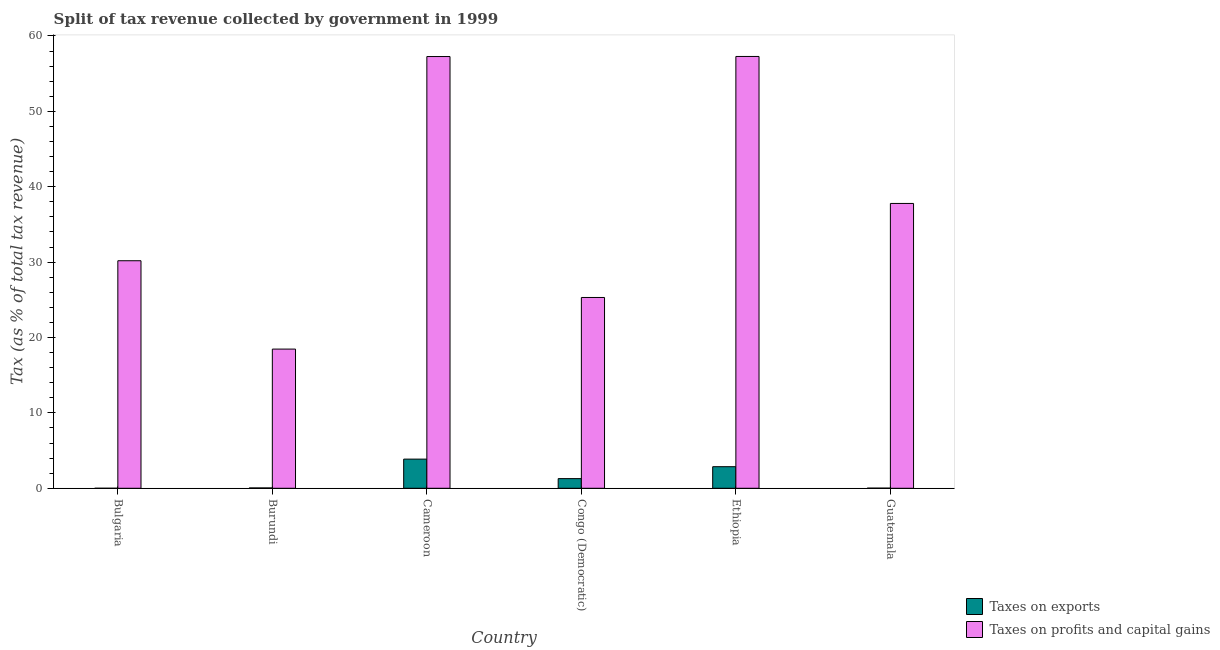How many different coloured bars are there?
Provide a short and direct response. 2. How many groups of bars are there?
Ensure brevity in your answer.  6. Are the number of bars per tick equal to the number of legend labels?
Offer a terse response. Yes. Are the number of bars on each tick of the X-axis equal?
Provide a succinct answer. Yes. How many bars are there on the 2nd tick from the right?
Make the answer very short. 2. What is the label of the 3rd group of bars from the left?
Your response must be concise. Cameroon. What is the percentage of revenue obtained from taxes on exports in Cameroon?
Ensure brevity in your answer.  3.87. Across all countries, what is the maximum percentage of revenue obtained from taxes on profits and capital gains?
Offer a very short reply. 57.28. Across all countries, what is the minimum percentage of revenue obtained from taxes on exports?
Ensure brevity in your answer.  0. In which country was the percentage of revenue obtained from taxes on exports maximum?
Ensure brevity in your answer.  Cameroon. In which country was the percentage of revenue obtained from taxes on profits and capital gains minimum?
Provide a succinct answer. Burundi. What is the total percentage of revenue obtained from taxes on profits and capital gains in the graph?
Provide a succinct answer. 226.28. What is the difference between the percentage of revenue obtained from taxes on exports in Ethiopia and that in Guatemala?
Your answer should be compact. 2.84. What is the difference between the percentage of revenue obtained from taxes on exports in Bulgaria and the percentage of revenue obtained from taxes on profits and capital gains in Burundi?
Give a very brief answer. -18.46. What is the average percentage of revenue obtained from taxes on exports per country?
Offer a very short reply. 1.35. What is the difference between the percentage of revenue obtained from taxes on exports and percentage of revenue obtained from taxes on profits and capital gains in Burundi?
Ensure brevity in your answer.  -18.42. What is the ratio of the percentage of revenue obtained from taxes on exports in Bulgaria to that in Congo (Democratic)?
Offer a very short reply. 0. Is the percentage of revenue obtained from taxes on exports in Burundi less than that in Cameroon?
Provide a succinct answer. Yes. What is the difference between the highest and the second highest percentage of revenue obtained from taxes on profits and capital gains?
Offer a very short reply. 0.01. What is the difference between the highest and the lowest percentage of revenue obtained from taxes on exports?
Provide a succinct answer. 3.87. What does the 1st bar from the left in Burundi represents?
Give a very brief answer. Taxes on exports. What does the 1st bar from the right in Ethiopia represents?
Ensure brevity in your answer.  Taxes on profits and capital gains. How many bars are there?
Make the answer very short. 12. Are all the bars in the graph horizontal?
Give a very brief answer. No. How many countries are there in the graph?
Make the answer very short. 6. Are the values on the major ticks of Y-axis written in scientific E-notation?
Make the answer very short. No. Does the graph contain grids?
Offer a very short reply. No. Where does the legend appear in the graph?
Keep it short and to the point. Bottom right. How many legend labels are there?
Provide a succinct answer. 2. What is the title of the graph?
Provide a succinct answer. Split of tax revenue collected by government in 1999. Does "Tetanus" appear as one of the legend labels in the graph?
Ensure brevity in your answer.  No. What is the label or title of the X-axis?
Ensure brevity in your answer.  Country. What is the label or title of the Y-axis?
Your answer should be very brief. Tax (as % of total tax revenue). What is the Tax (as % of total tax revenue) in Taxes on exports in Bulgaria?
Provide a succinct answer. 0. What is the Tax (as % of total tax revenue) of Taxes on profits and capital gains in Bulgaria?
Offer a terse response. 30.18. What is the Tax (as % of total tax revenue) in Taxes on exports in Burundi?
Provide a short and direct response. 0.05. What is the Tax (as % of total tax revenue) in Taxes on profits and capital gains in Burundi?
Offer a very short reply. 18.46. What is the Tax (as % of total tax revenue) in Taxes on exports in Cameroon?
Keep it short and to the point. 3.87. What is the Tax (as % of total tax revenue) in Taxes on profits and capital gains in Cameroon?
Your answer should be compact. 57.27. What is the Tax (as % of total tax revenue) of Taxes on exports in Congo (Democratic)?
Provide a short and direct response. 1.28. What is the Tax (as % of total tax revenue) in Taxes on profits and capital gains in Congo (Democratic)?
Give a very brief answer. 25.31. What is the Tax (as % of total tax revenue) of Taxes on exports in Ethiopia?
Provide a succinct answer. 2.86. What is the Tax (as % of total tax revenue) of Taxes on profits and capital gains in Ethiopia?
Your answer should be very brief. 57.28. What is the Tax (as % of total tax revenue) of Taxes on exports in Guatemala?
Keep it short and to the point. 0.02. What is the Tax (as % of total tax revenue) of Taxes on profits and capital gains in Guatemala?
Provide a succinct answer. 37.78. Across all countries, what is the maximum Tax (as % of total tax revenue) in Taxes on exports?
Your response must be concise. 3.87. Across all countries, what is the maximum Tax (as % of total tax revenue) in Taxes on profits and capital gains?
Provide a succinct answer. 57.28. Across all countries, what is the minimum Tax (as % of total tax revenue) of Taxes on exports?
Your response must be concise. 0. Across all countries, what is the minimum Tax (as % of total tax revenue) of Taxes on profits and capital gains?
Give a very brief answer. 18.46. What is the total Tax (as % of total tax revenue) of Taxes on exports in the graph?
Keep it short and to the point. 8.08. What is the total Tax (as % of total tax revenue) of Taxes on profits and capital gains in the graph?
Ensure brevity in your answer.  226.28. What is the difference between the Tax (as % of total tax revenue) in Taxes on exports in Bulgaria and that in Burundi?
Provide a succinct answer. -0.04. What is the difference between the Tax (as % of total tax revenue) of Taxes on profits and capital gains in Bulgaria and that in Burundi?
Give a very brief answer. 11.72. What is the difference between the Tax (as % of total tax revenue) of Taxes on exports in Bulgaria and that in Cameroon?
Provide a short and direct response. -3.87. What is the difference between the Tax (as % of total tax revenue) of Taxes on profits and capital gains in Bulgaria and that in Cameroon?
Offer a very short reply. -27.08. What is the difference between the Tax (as % of total tax revenue) of Taxes on exports in Bulgaria and that in Congo (Democratic)?
Your response must be concise. -1.28. What is the difference between the Tax (as % of total tax revenue) of Taxes on profits and capital gains in Bulgaria and that in Congo (Democratic)?
Provide a succinct answer. 4.87. What is the difference between the Tax (as % of total tax revenue) in Taxes on exports in Bulgaria and that in Ethiopia?
Ensure brevity in your answer.  -2.86. What is the difference between the Tax (as % of total tax revenue) in Taxes on profits and capital gains in Bulgaria and that in Ethiopia?
Give a very brief answer. -27.09. What is the difference between the Tax (as % of total tax revenue) of Taxes on exports in Bulgaria and that in Guatemala?
Give a very brief answer. -0.02. What is the difference between the Tax (as % of total tax revenue) of Taxes on profits and capital gains in Bulgaria and that in Guatemala?
Keep it short and to the point. -7.6. What is the difference between the Tax (as % of total tax revenue) of Taxes on exports in Burundi and that in Cameroon?
Keep it short and to the point. -3.82. What is the difference between the Tax (as % of total tax revenue) of Taxes on profits and capital gains in Burundi and that in Cameroon?
Keep it short and to the point. -38.8. What is the difference between the Tax (as % of total tax revenue) of Taxes on exports in Burundi and that in Congo (Democratic)?
Provide a succinct answer. -1.24. What is the difference between the Tax (as % of total tax revenue) of Taxes on profits and capital gains in Burundi and that in Congo (Democratic)?
Your answer should be very brief. -6.85. What is the difference between the Tax (as % of total tax revenue) of Taxes on exports in Burundi and that in Ethiopia?
Your answer should be compact. -2.82. What is the difference between the Tax (as % of total tax revenue) of Taxes on profits and capital gains in Burundi and that in Ethiopia?
Ensure brevity in your answer.  -38.81. What is the difference between the Tax (as % of total tax revenue) in Taxes on exports in Burundi and that in Guatemala?
Offer a terse response. 0.03. What is the difference between the Tax (as % of total tax revenue) in Taxes on profits and capital gains in Burundi and that in Guatemala?
Make the answer very short. -19.32. What is the difference between the Tax (as % of total tax revenue) of Taxes on exports in Cameroon and that in Congo (Democratic)?
Offer a terse response. 2.59. What is the difference between the Tax (as % of total tax revenue) in Taxes on profits and capital gains in Cameroon and that in Congo (Democratic)?
Your answer should be very brief. 31.96. What is the difference between the Tax (as % of total tax revenue) in Taxes on exports in Cameroon and that in Ethiopia?
Give a very brief answer. 1. What is the difference between the Tax (as % of total tax revenue) in Taxes on profits and capital gains in Cameroon and that in Ethiopia?
Keep it short and to the point. -0.01. What is the difference between the Tax (as % of total tax revenue) of Taxes on exports in Cameroon and that in Guatemala?
Offer a very short reply. 3.85. What is the difference between the Tax (as % of total tax revenue) of Taxes on profits and capital gains in Cameroon and that in Guatemala?
Your answer should be compact. 19.49. What is the difference between the Tax (as % of total tax revenue) of Taxes on exports in Congo (Democratic) and that in Ethiopia?
Keep it short and to the point. -1.58. What is the difference between the Tax (as % of total tax revenue) of Taxes on profits and capital gains in Congo (Democratic) and that in Ethiopia?
Provide a short and direct response. -31.97. What is the difference between the Tax (as % of total tax revenue) of Taxes on exports in Congo (Democratic) and that in Guatemala?
Give a very brief answer. 1.26. What is the difference between the Tax (as % of total tax revenue) in Taxes on profits and capital gains in Congo (Democratic) and that in Guatemala?
Provide a short and direct response. -12.47. What is the difference between the Tax (as % of total tax revenue) in Taxes on exports in Ethiopia and that in Guatemala?
Your response must be concise. 2.85. What is the difference between the Tax (as % of total tax revenue) of Taxes on profits and capital gains in Ethiopia and that in Guatemala?
Give a very brief answer. 19.5. What is the difference between the Tax (as % of total tax revenue) in Taxes on exports in Bulgaria and the Tax (as % of total tax revenue) in Taxes on profits and capital gains in Burundi?
Your answer should be compact. -18.46. What is the difference between the Tax (as % of total tax revenue) in Taxes on exports in Bulgaria and the Tax (as % of total tax revenue) in Taxes on profits and capital gains in Cameroon?
Make the answer very short. -57.26. What is the difference between the Tax (as % of total tax revenue) of Taxes on exports in Bulgaria and the Tax (as % of total tax revenue) of Taxes on profits and capital gains in Congo (Democratic)?
Your answer should be very brief. -25.31. What is the difference between the Tax (as % of total tax revenue) of Taxes on exports in Bulgaria and the Tax (as % of total tax revenue) of Taxes on profits and capital gains in Ethiopia?
Your answer should be very brief. -57.27. What is the difference between the Tax (as % of total tax revenue) in Taxes on exports in Bulgaria and the Tax (as % of total tax revenue) in Taxes on profits and capital gains in Guatemala?
Offer a terse response. -37.78. What is the difference between the Tax (as % of total tax revenue) of Taxes on exports in Burundi and the Tax (as % of total tax revenue) of Taxes on profits and capital gains in Cameroon?
Keep it short and to the point. -57.22. What is the difference between the Tax (as % of total tax revenue) of Taxes on exports in Burundi and the Tax (as % of total tax revenue) of Taxes on profits and capital gains in Congo (Democratic)?
Ensure brevity in your answer.  -25.26. What is the difference between the Tax (as % of total tax revenue) of Taxes on exports in Burundi and the Tax (as % of total tax revenue) of Taxes on profits and capital gains in Ethiopia?
Offer a terse response. -57.23. What is the difference between the Tax (as % of total tax revenue) in Taxes on exports in Burundi and the Tax (as % of total tax revenue) in Taxes on profits and capital gains in Guatemala?
Provide a succinct answer. -37.73. What is the difference between the Tax (as % of total tax revenue) in Taxes on exports in Cameroon and the Tax (as % of total tax revenue) in Taxes on profits and capital gains in Congo (Democratic)?
Ensure brevity in your answer.  -21.44. What is the difference between the Tax (as % of total tax revenue) in Taxes on exports in Cameroon and the Tax (as % of total tax revenue) in Taxes on profits and capital gains in Ethiopia?
Offer a very short reply. -53.41. What is the difference between the Tax (as % of total tax revenue) of Taxes on exports in Cameroon and the Tax (as % of total tax revenue) of Taxes on profits and capital gains in Guatemala?
Offer a terse response. -33.91. What is the difference between the Tax (as % of total tax revenue) in Taxes on exports in Congo (Democratic) and the Tax (as % of total tax revenue) in Taxes on profits and capital gains in Ethiopia?
Make the answer very short. -55.99. What is the difference between the Tax (as % of total tax revenue) in Taxes on exports in Congo (Democratic) and the Tax (as % of total tax revenue) in Taxes on profits and capital gains in Guatemala?
Ensure brevity in your answer.  -36.5. What is the difference between the Tax (as % of total tax revenue) in Taxes on exports in Ethiopia and the Tax (as % of total tax revenue) in Taxes on profits and capital gains in Guatemala?
Provide a succinct answer. -34.92. What is the average Tax (as % of total tax revenue) in Taxes on exports per country?
Offer a terse response. 1.35. What is the average Tax (as % of total tax revenue) of Taxes on profits and capital gains per country?
Your answer should be compact. 37.71. What is the difference between the Tax (as % of total tax revenue) of Taxes on exports and Tax (as % of total tax revenue) of Taxes on profits and capital gains in Bulgaria?
Ensure brevity in your answer.  -30.18. What is the difference between the Tax (as % of total tax revenue) of Taxes on exports and Tax (as % of total tax revenue) of Taxes on profits and capital gains in Burundi?
Offer a very short reply. -18.42. What is the difference between the Tax (as % of total tax revenue) in Taxes on exports and Tax (as % of total tax revenue) in Taxes on profits and capital gains in Cameroon?
Offer a very short reply. -53.4. What is the difference between the Tax (as % of total tax revenue) in Taxes on exports and Tax (as % of total tax revenue) in Taxes on profits and capital gains in Congo (Democratic)?
Provide a short and direct response. -24.03. What is the difference between the Tax (as % of total tax revenue) in Taxes on exports and Tax (as % of total tax revenue) in Taxes on profits and capital gains in Ethiopia?
Make the answer very short. -54.41. What is the difference between the Tax (as % of total tax revenue) of Taxes on exports and Tax (as % of total tax revenue) of Taxes on profits and capital gains in Guatemala?
Ensure brevity in your answer.  -37.76. What is the ratio of the Tax (as % of total tax revenue) in Taxes on exports in Bulgaria to that in Burundi?
Ensure brevity in your answer.  0.03. What is the ratio of the Tax (as % of total tax revenue) of Taxes on profits and capital gains in Bulgaria to that in Burundi?
Provide a short and direct response. 1.63. What is the ratio of the Tax (as % of total tax revenue) of Taxes on exports in Bulgaria to that in Cameroon?
Give a very brief answer. 0. What is the ratio of the Tax (as % of total tax revenue) in Taxes on profits and capital gains in Bulgaria to that in Cameroon?
Keep it short and to the point. 0.53. What is the ratio of the Tax (as % of total tax revenue) of Taxes on exports in Bulgaria to that in Congo (Democratic)?
Keep it short and to the point. 0. What is the ratio of the Tax (as % of total tax revenue) of Taxes on profits and capital gains in Bulgaria to that in Congo (Democratic)?
Provide a succinct answer. 1.19. What is the ratio of the Tax (as % of total tax revenue) of Taxes on exports in Bulgaria to that in Ethiopia?
Give a very brief answer. 0. What is the ratio of the Tax (as % of total tax revenue) of Taxes on profits and capital gains in Bulgaria to that in Ethiopia?
Your answer should be compact. 0.53. What is the ratio of the Tax (as % of total tax revenue) in Taxes on exports in Bulgaria to that in Guatemala?
Make the answer very short. 0.08. What is the ratio of the Tax (as % of total tax revenue) of Taxes on profits and capital gains in Bulgaria to that in Guatemala?
Offer a terse response. 0.8. What is the ratio of the Tax (as % of total tax revenue) of Taxes on exports in Burundi to that in Cameroon?
Keep it short and to the point. 0.01. What is the ratio of the Tax (as % of total tax revenue) in Taxes on profits and capital gains in Burundi to that in Cameroon?
Give a very brief answer. 0.32. What is the ratio of the Tax (as % of total tax revenue) in Taxes on exports in Burundi to that in Congo (Democratic)?
Your response must be concise. 0.04. What is the ratio of the Tax (as % of total tax revenue) in Taxes on profits and capital gains in Burundi to that in Congo (Democratic)?
Make the answer very short. 0.73. What is the ratio of the Tax (as % of total tax revenue) in Taxes on exports in Burundi to that in Ethiopia?
Offer a terse response. 0.02. What is the ratio of the Tax (as % of total tax revenue) in Taxes on profits and capital gains in Burundi to that in Ethiopia?
Your answer should be compact. 0.32. What is the ratio of the Tax (as % of total tax revenue) in Taxes on exports in Burundi to that in Guatemala?
Make the answer very short. 2.44. What is the ratio of the Tax (as % of total tax revenue) in Taxes on profits and capital gains in Burundi to that in Guatemala?
Offer a very short reply. 0.49. What is the ratio of the Tax (as % of total tax revenue) of Taxes on exports in Cameroon to that in Congo (Democratic)?
Your answer should be compact. 3.02. What is the ratio of the Tax (as % of total tax revenue) in Taxes on profits and capital gains in Cameroon to that in Congo (Democratic)?
Ensure brevity in your answer.  2.26. What is the ratio of the Tax (as % of total tax revenue) of Taxes on exports in Cameroon to that in Ethiopia?
Offer a very short reply. 1.35. What is the ratio of the Tax (as % of total tax revenue) in Taxes on exports in Cameroon to that in Guatemala?
Give a very brief answer. 205.47. What is the ratio of the Tax (as % of total tax revenue) in Taxes on profits and capital gains in Cameroon to that in Guatemala?
Your response must be concise. 1.52. What is the ratio of the Tax (as % of total tax revenue) of Taxes on exports in Congo (Democratic) to that in Ethiopia?
Offer a terse response. 0.45. What is the ratio of the Tax (as % of total tax revenue) of Taxes on profits and capital gains in Congo (Democratic) to that in Ethiopia?
Your answer should be compact. 0.44. What is the ratio of the Tax (as % of total tax revenue) in Taxes on exports in Congo (Democratic) to that in Guatemala?
Your answer should be very brief. 68.13. What is the ratio of the Tax (as % of total tax revenue) in Taxes on profits and capital gains in Congo (Democratic) to that in Guatemala?
Your answer should be very brief. 0.67. What is the ratio of the Tax (as % of total tax revenue) in Taxes on exports in Ethiopia to that in Guatemala?
Your answer should be compact. 152.11. What is the ratio of the Tax (as % of total tax revenue) of Taxes on profits and capital gains in Ethiopia to that in Guatemala?
Provide a short and direct response. 1.52. What is the difference between the highest and the second highest Tax (as % of total tax revenue) in Taxes on exports?
Your answer should be compact. 1. What is the difference between the highest and the second highest Tax (as % of total tax revenue) of Taxes on profits and capital gains?
Provide a succinct answer. 0.01. What is the difference between the highest and the lowest Tax (as % of total tax revenue) of Taxes on exports?
Your response must be concise. 3.87. What is the difference between the highest and the lowest Tax (as % of total tax revenue) of Taxes on profits and capital gains?
Your answer should be compact. 38.81. 